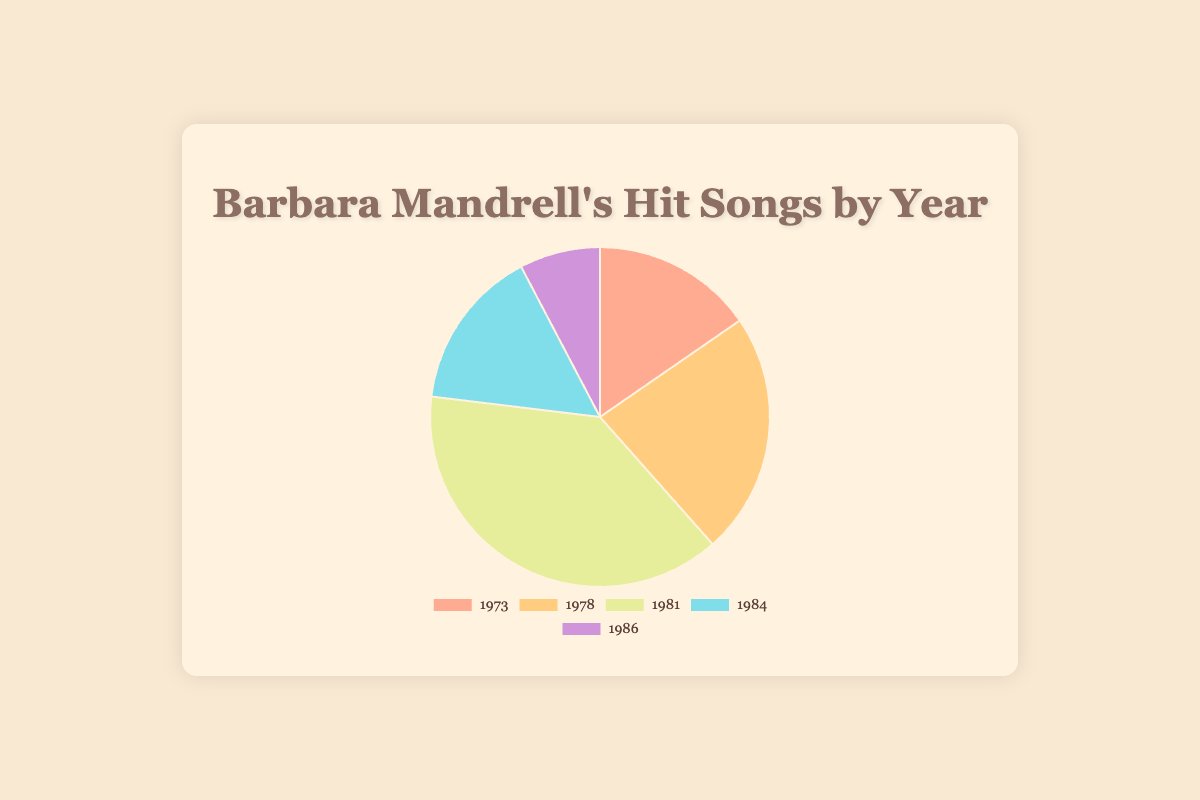What year had the highest number of hit songs for Barbara Mandrell? The highest number of hit songs is indicated by the largest slice of the pie chart. In 1981, there were 5 hit songs, which is the largest number in the data set.
Answer: 1981 How many total hit songs did Barbara Mandrell have in the years 1984 and 1986 combined? To find this, add the number of hit songs in 1984 (2) and 1986 (1). The combined total is 2 + 1.
Answer: 3 Which year had more hit songs: 1973 or 1984? Compare the number of hit songs in 1973 (2) and 1984 (2). Both years had 2 hit songs.
Answer: Equal What is the average number of hit songs per year? There are 5 data points: 2 (1973), 3 (1978), 5 (1981), 2 (1984), 1 (1986). Sum these numbers: 2 + 3 + 5 + 2 + 1 = 13. Divide by 5 to find the average: 13 / 5.
Answer: 2.6 Which year had the smallest number of hit songs, and what was the count? The year with the smallest number of hit songs has the smallest slice in the pie chart. In 1986, there was only 1 hit song, which is the smallest number in the data set.
Answer: 1986, 1 How does the number of hit songs in 1978 compare with the number in 1981? In 1978, there were 3 hit songs, and in 1981, there were 5 hit songs. Since 5 is greater than 3, 1981 had more hit songs than 1978.
Answer: 1981 had more What is the difference in the number of hit songs between the years with the highest and the lowest counts? The highest number of hit songs in a year is 5 (1981), and the lowest is 1 (1986). Subtract the lowest count from the highest: 5 - 1.
Answer: 4 How many years had exactly 2 hit songs? Observing the pie chart, the years 1973 and 1984 each had 2 hit songs, which means there are two years with exactly 2 hit songs.
Answer: 2 Which color represents the year 1978 in the pie chart? The legend of the pie chart uses different colors for each year. The year 1978 is represented by the second color, which is an orange shade.
Answer: Orange Calculate the proportion of hit songs in 1981 out of the total hit songs. The total number of hit songs is 13. The number of hit songs in 1981 is 5. The proportion is calculated as 5 / 13.
Answer: 5/13 